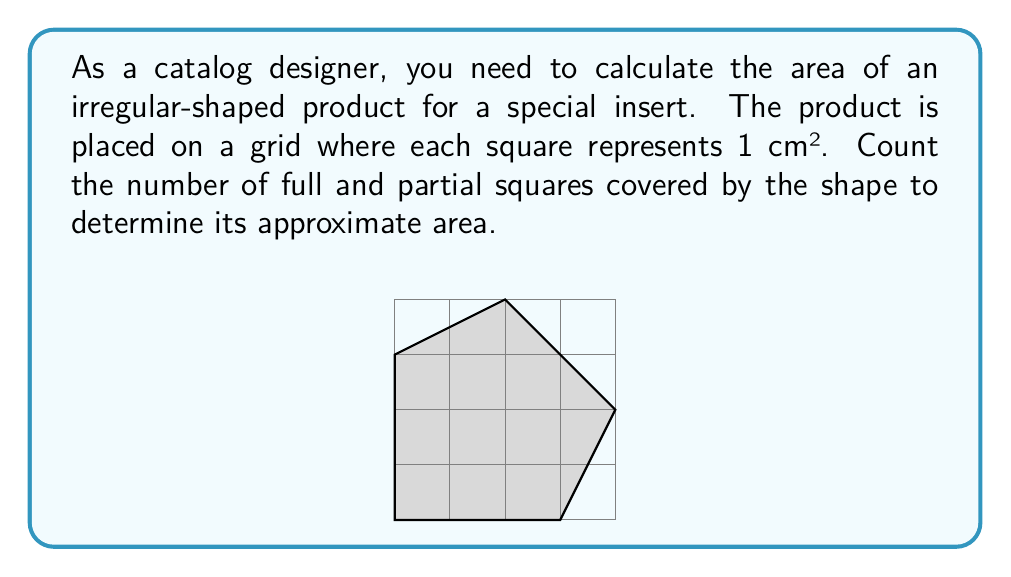Teach me how to tackle this problem. To calculate the area of this irregular polygon using the grid method, we'll follow these steps:

1. Count the number of full squares entirely within the shape:
   There are 5 full squares.

2. Count the number of partial squares:
   There are 11 partial squares.

3. Estimate the area of partial squares:
   We can approximate each partial square as half a square.
   Estimated area of partial squares: $11 \times 0.5 = 5.5$ cm²

4. Calculate the total area:
   $$\text{Total Area} = \text{Full Squares} + \text{Estimated Partial Squares}$$
   $$\text{Total Area} = 5 + 5.5 = 10.5\text{ cm}^2$$

This method provides a reasonable approximation of the irregular shape's area, suitable for catalog design purposes where precise measurements may not be critical.
Answer: $10.5\text{ cm}^2$ 